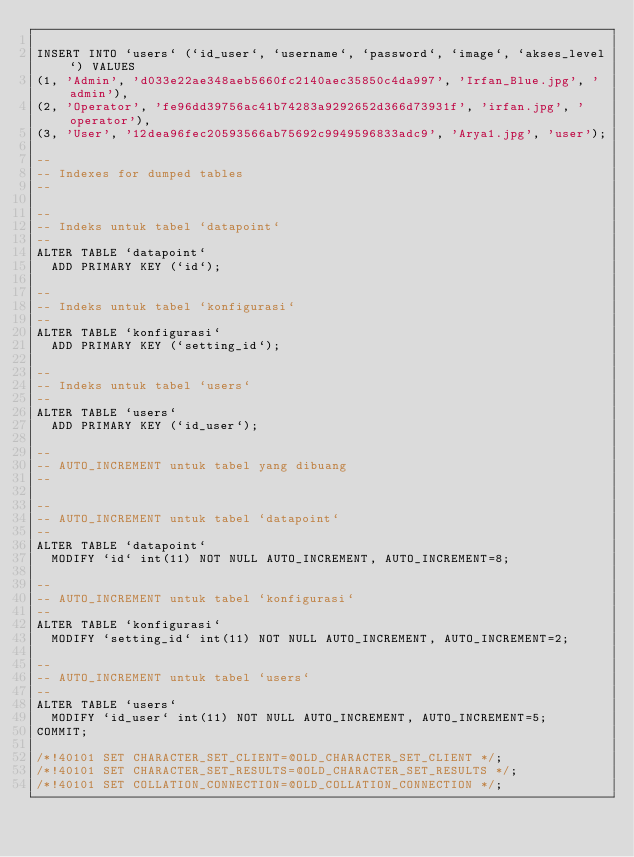<code> <loc_0><loc_0><loc_500><loc_500><_SQL_>
INSERT INTO `users` (`id_user`, `username`, `password`, `image`, `akses_level`) VALUES
(1, 'Admin', 'd033e22ae348aeb5660fc2140aec35850c4da997', 'Irfan_Blue.jpg', 'admin'),
(2, 'Operator', 'fe96dd39756ac41b74283a9292652d366d73931f', 'irfan.jpg', 'operator'),
(3, 'User', '12dea96fec20593566ab75692c9949596833adc9', 'Arya1.jpg', 'user');

--
-- Indexes for dumped tables
--

--
-- Indeks untuk tabel `datapoint`
--
ALTER TABLE `datapoint`
  ADD PRIMARY KEY (`id`);

--
-- Indeks untuk tabel `konfigurasi`
--
ALTER TABLE `konfigurasi`
  ADD PRIMARY KEY (`setting_id`);

--
-- Indeks untuk tabel `users`
--
ALTER TABLE `users`
  ADD PRIMARY KEY (`id_user`);

--
-- AUTO_INCREMENT untuk tabel yang dibuang
--

--
-- AUTO_INCREMENT untuk tabel `datapoint`
--
ALTER TABLE `datapoint`
  MODIFY `id` int(11) NOT NULL AUTO_INCREMENT, AUTO_INCREMENT=8;

--
-- AUTO_INCREMENT untuk tabel `konfigurasi`
--
ALTER TABLE `konfigurasi`
  MODIFY `setting_id` int(11) NOT NULL AUTO_INCREMENT, AUTO_INCREMENT=2;

--
-- AUTO_INCREMENT untuk tabel `users`
--
ALTER TABLE `users`
  MODIFY `id_user` int(11) NOT NULL AUTO_INCREMENT, AUTO_INCREMENT=5;
COMMIT;

/*!40101 SET CHARACTER_SET_CLIENT=@OLD_CHARACTER_SET_CLIENT */;
/*!40101 SET CHARACTER_SET_RESULTS=@OLD_CHARACTER_SET_RESULTS */;
/*!40101 SET COLLATION_CONNECTION=@OLD_COLLATION_CONNECTION */;
</code> 